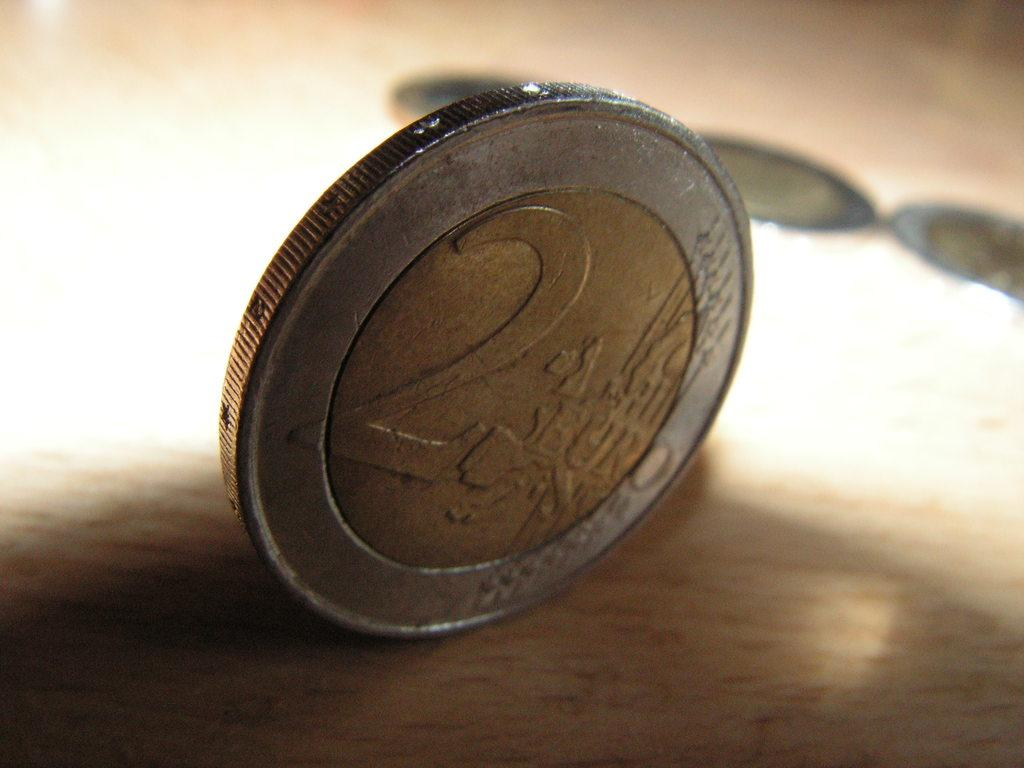<image>
Render a clear and concise summary of the photo. a round coin with the number 2 and the word euro on it 